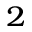Convert formula to latex. <formula><loc_0><loc_0><loc_500><loc_500>_ { 2 }</formula> 